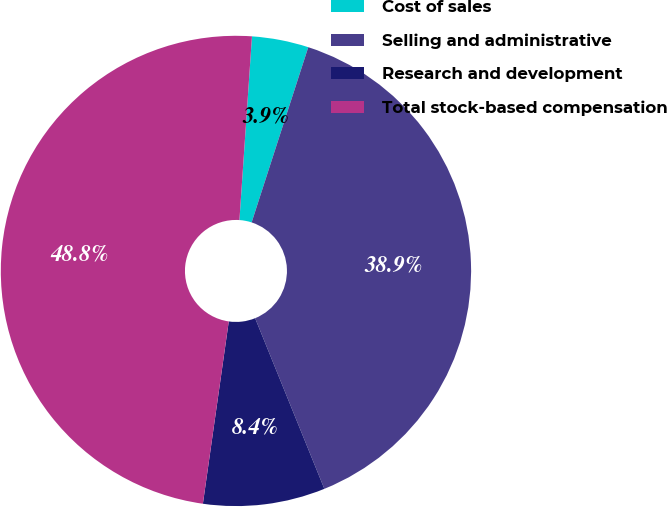Convert chart. <chart><loc_0><loc_0><loc_500><loc_500><pie_chart><fcel>Cost of sales<fcel>Selling and administrative<fcel>Research and development<fcel>Total stock-based compensation<nl><fcel>3.89%<fcel>38.89%<fcel>8.38%<fcel>48.84%<nl></chart> 